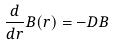Convert formula to latex. <formula><loc_0><loc_0><loc_500><loc_500>\frac { d } { d r } B ( r ) = - D B</formula> 